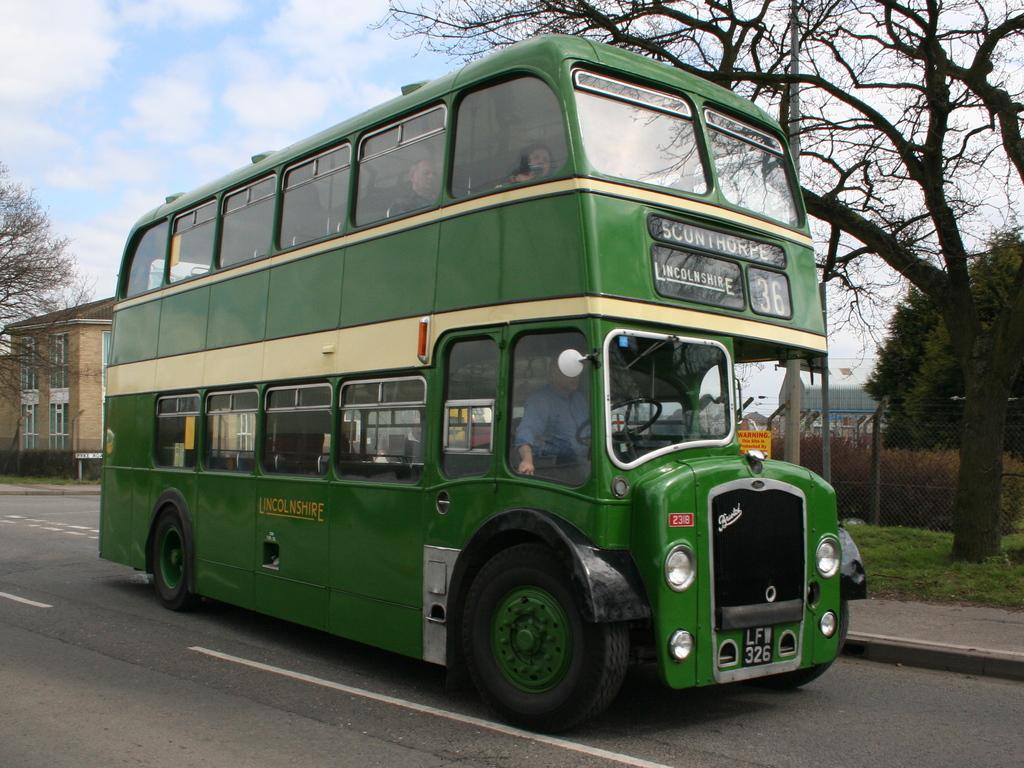<image>
Offer a succinct explanation of the picture presented. Scunthorpe Lincolnshire 36 is displayed on the front of this bus. 